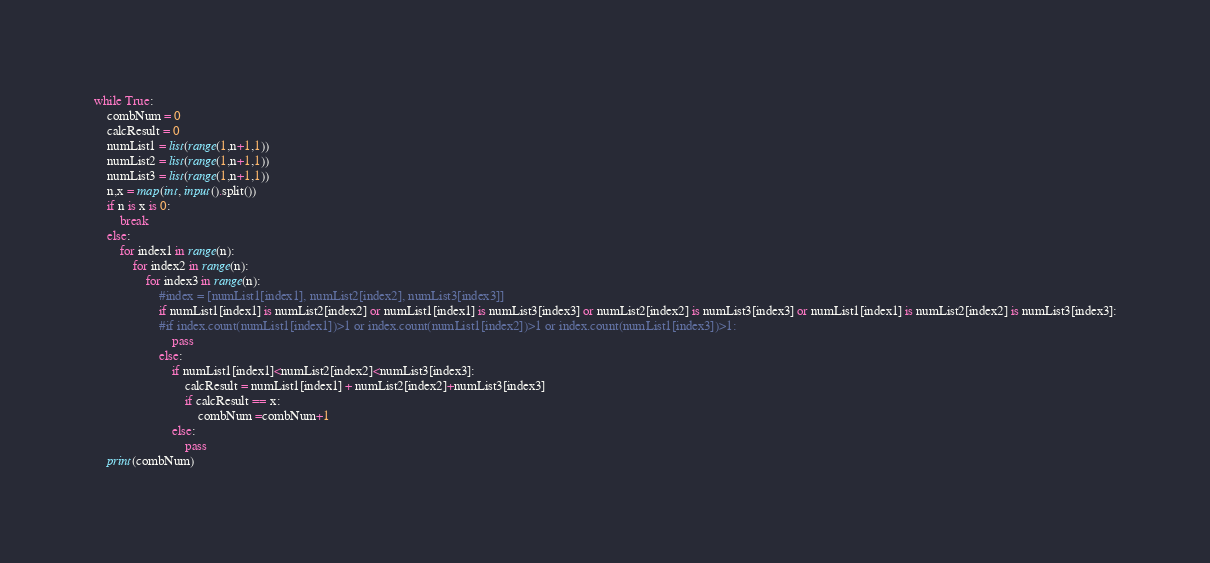Convert code to text. <code><loc_0><loc_0><loc_500><loc_500><_Python_>while True:
    combNum = 0
    calcResult = 0
    numList1 = list(range(1,n+1,1))
    numList2 = list(range(1,n+1,1))
    numList3 = list(range(1,n+1,1))
    n,x = map(int, input().split())
    if n is x is 0:
        break
    else:
        for index1 in range(n):
            for index2 in range(n):
                for index3 in range(n):
                    #index = [numList1[index1], numList2[index2], numList3[index3]]
                    if numList1[index1] is numList2[index2] or numList1[index1] is numList3[index3] or numList2[index2] is numList3[index3] or numList1[index1] is numList2[index2] is numList3[index3]:
                    #if index.count(numList1[index1])>1 or index.count(numList1[index2])>1 or index.count(numList1[index3])>1:
                        pass                
                    else:
                        if numList1[index1]<numList2[index2]<numList3[index3]:
                            calcResult = numList1[index1] + numList2[index2]+numList3[index3]
                            if calcResult == x:
                                combNum =combNum+1
                        else:
                            pass
    print(combNum)
</code> 